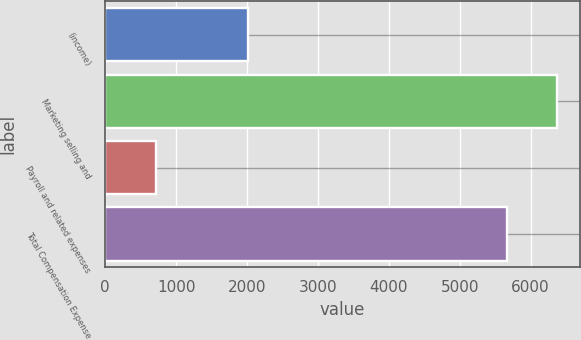Convert chart. <chart><loc_0><loc_0><loc_500><loc_500><bar_chart><fcel>(income)<fcel>Marketing selling and<fcel>Payroll and related expenses<fcel>Total Compensation Expense<nl><fcel>2008<fcel>6373<fcel>712<fcel>5661<nl></chart> 